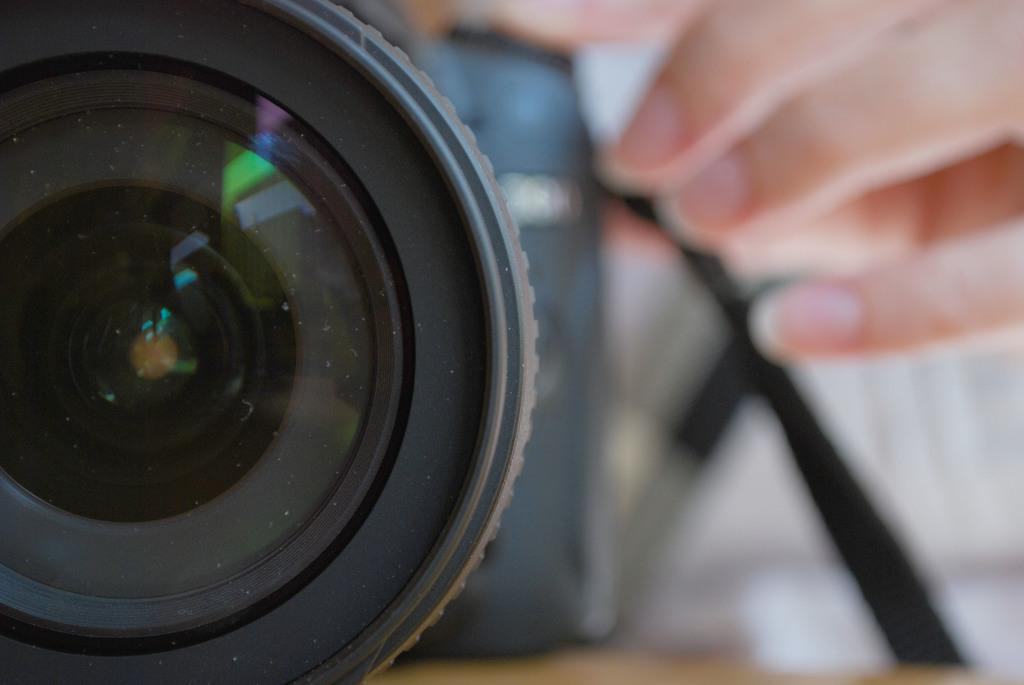What object is the main focus of the image? There is a camera in the image. Can you describe any other elements in the image? There are fingers of a person visible in the background of the image. What type of insurance does the person's brother have in the image? There is no mention of a brother or insurance in the image, so it cannot be determined from the image. 